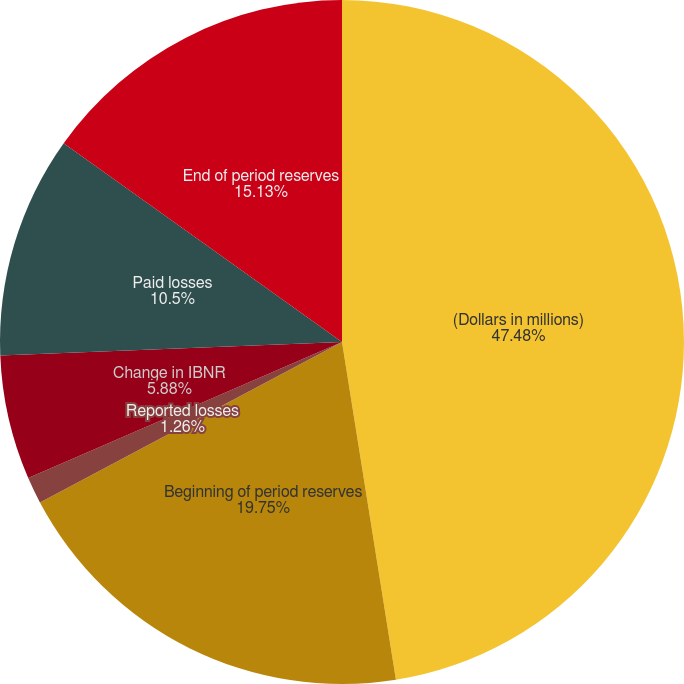<chart> <loc_0><loc_0><loc_500><loc_500><pie_chart><fcel>(Dollars in millions)<fcel>Beginning of period reserves<fcel>Reported losses<fcel>Change in IBNR<fcel>Paid losses<fcel>End of period reserves<nl><fcel>47.48%<fcel>19.75%<fcel>1.26%<fcel>5.88%<fcel>10.5%<fcel>15.13%<nl></chart> 